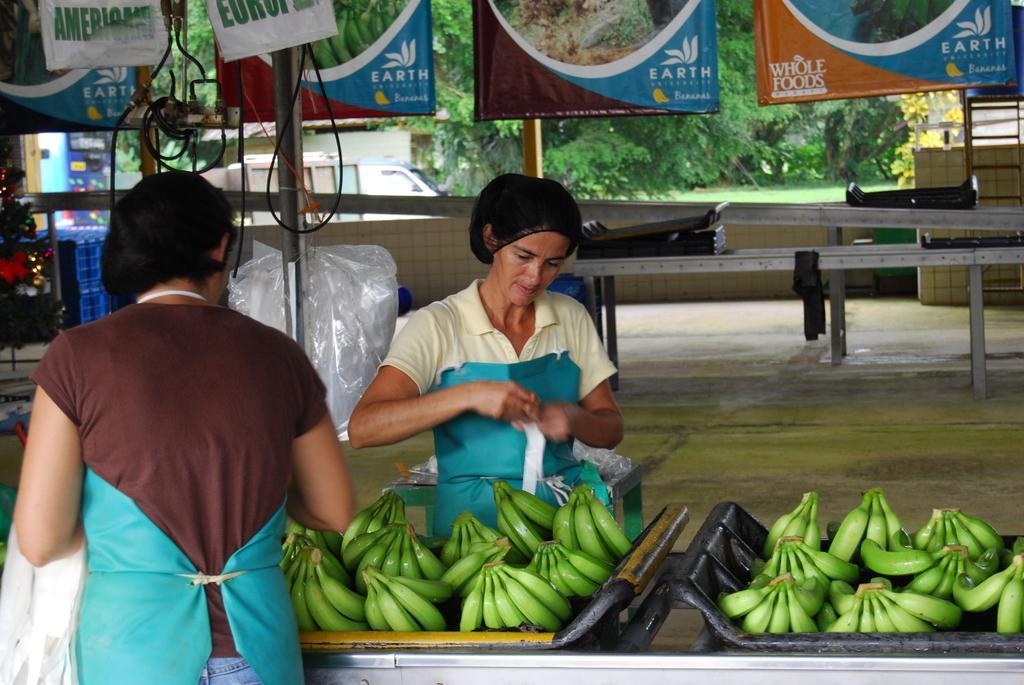Describe this image in one or two sentences. In this image I can see two persons standing. There are bananas on trays. There are poles, banners, cables, trees and there is a vehicle. Also there are some other objects. 